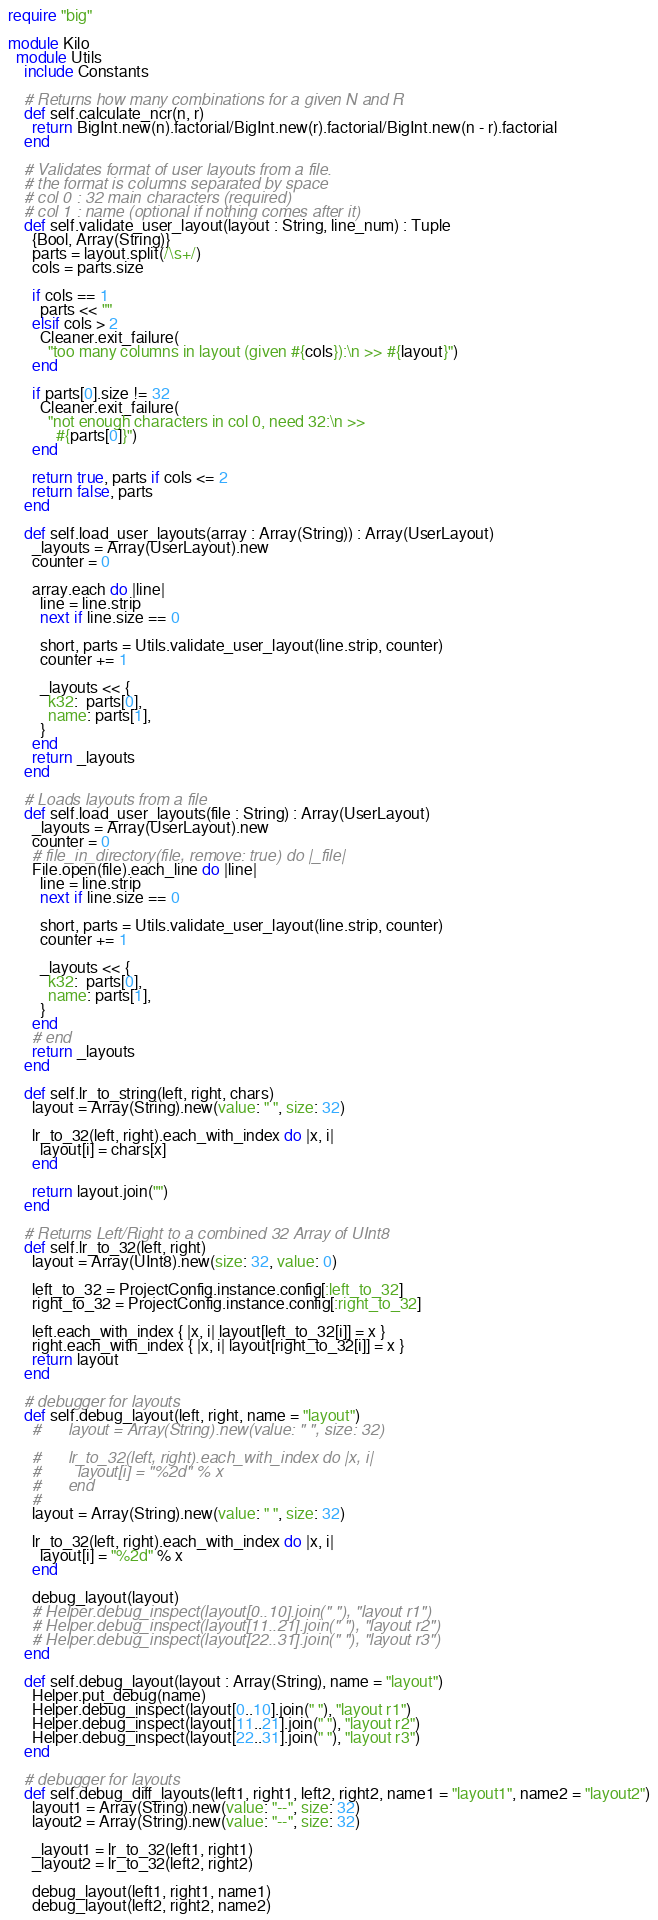<code> <loc_0><loc_0><loc_500><loc_500><_Crystal_>require "big"

module Kilo
  module Utils
    include Constants

    # Returns how many combinations for a given N and R
    def self.calculate_ncr(n, r)
      return BigInt.new(n).factorial/BigInt.new(r).factorial/BigInt.new(n - r).factorial
    end

    # Validates format of user layouts from a file.
    # the format is columns separated by space
    # col 0 : 32 main characters (required)
    # col 1 : name (optional if nothing comes after it)
    def self.validate_user_layout(layout : String, line_num) : Tuple
      {Bool, Array(String)}
      parts = layout.split(/\s+/)
      cols = parts.size

      if cols == 1
        parts << ""
      elsif cols > 2
        Cleaner.exit_failure(
          "too many columns in layout (given #{cols}):\n >> #{layout}")
      end

      if parts[0].size != 32
        Cleaner.exit_failure(
          "not enough characters in col 0, need 32:\n >>
            #{parts[0]}")
      end

      return true, parts if cols <= 2
      return false, parts
    end

    def self.load_user_layouts(array : Array(String)) : Array(UserLayout)
      _layouts = Array(UserLayout).new
      counter = 0

      array.each do |line|
        line = line.strip
        next if line.size == 0

        short, parts = Utils.validate_user_layout(line.strip, counter)
        counter += 1

        _layouts << {
          k32:  parts[0],
          name: parts[1],
        }
      end
      return _layouts
    end

    # Loads layouts from a file
    def self.load_user_layouts(file : String) : Array(UserLayout)
      _layouts = Array(UserLayout).new
      counter = 0
      # file_in_directory(file, remove: true) do |_file|
      File.open(file).each_line do |line|
        line = line.strip
        next if line.size == 0

        short, parts = Utils.validate_user_layout(line.strip, counter)
        counter += 1

        _layouts << {
          k32:  parts[0],
          name: parts[1],
        }
      end
      # end
      return _layouts
    end

    def self.lr_to_string(left, right, chars)
      layout = Array(String).new(value: " ", size: 32)

      lr_to_32(left, right).each_with_index do |x, i|
        layout[i] = chars[x]
      end

      return layout.join("")
    end

    # Returns Left/Right to a combined 32 Array of UInt8
    def self.lr_to_32(left, right)
      layout = Array(UInt8).new(size: 32, value: 0)

      left_to_32 = ProjectConfig.instance.config[:left_to_32]
      right_to_32 = ProjectConfig.instance.config[:right_to_32]

      left.each_with_index { |x, i| layout[left_to_32[i]] = x }
      right.each_with_index { |x, i| layout[right_to_32[i]] = x }
      return layout
    end

    # debugger for layouts
    def self.debug_layout(left, right, name = "layout")
      #      layout = Array(String).new(value: " ", size: 32)

      #      lr_to_32(left, right).each_with_index do |x, i|
      #        layout[i] = "%2d" % x
      #      end
      #
      layout = Array(String).new(value: " ", size: 32)

      lr_to_32(left, right).each_with_index do |x, i|
        layout[i] = "%2d" % x
      end

      debug_layout(layout)
      # Helper.debug_inspect(layout[0..10].join(" "), "layout r1")
      # Helper.debug_inspect(layout[11..21].join(" "), "layout r2")
      # Helper.debug_inspect(layout[22..31].join(" "), "layout r3")
    end

    def self.debug_layout(layout : Array(String), name = "layout")
      Helper.put_debug(name)
      Helper.debug_inspect(layout[0..10].join(" "), "layout r1")
      Helper.debug_inspect(layout[11..21].join(" "), "layout r2")
      Helper.debug_inspect(layout[22..31].join(" "), "layout r3")
    end

    # debugger for layouts
    def self.debug_diff_layouts(left1, right1, left2, right2, name1 = "layout1", name2 = "layout2")
      layout1 = Array(String).new(value: "--", size: 32)
      layout2 = Array(String).new(value: "--", size: 32)

      _layout1 = lr_to_32(left1, right1)
      _layout2 = lr_to_32(left2, right2)

      debug_layout(left1, right1, name1)
      debug_layout(left2, right2, name2)
</code> 